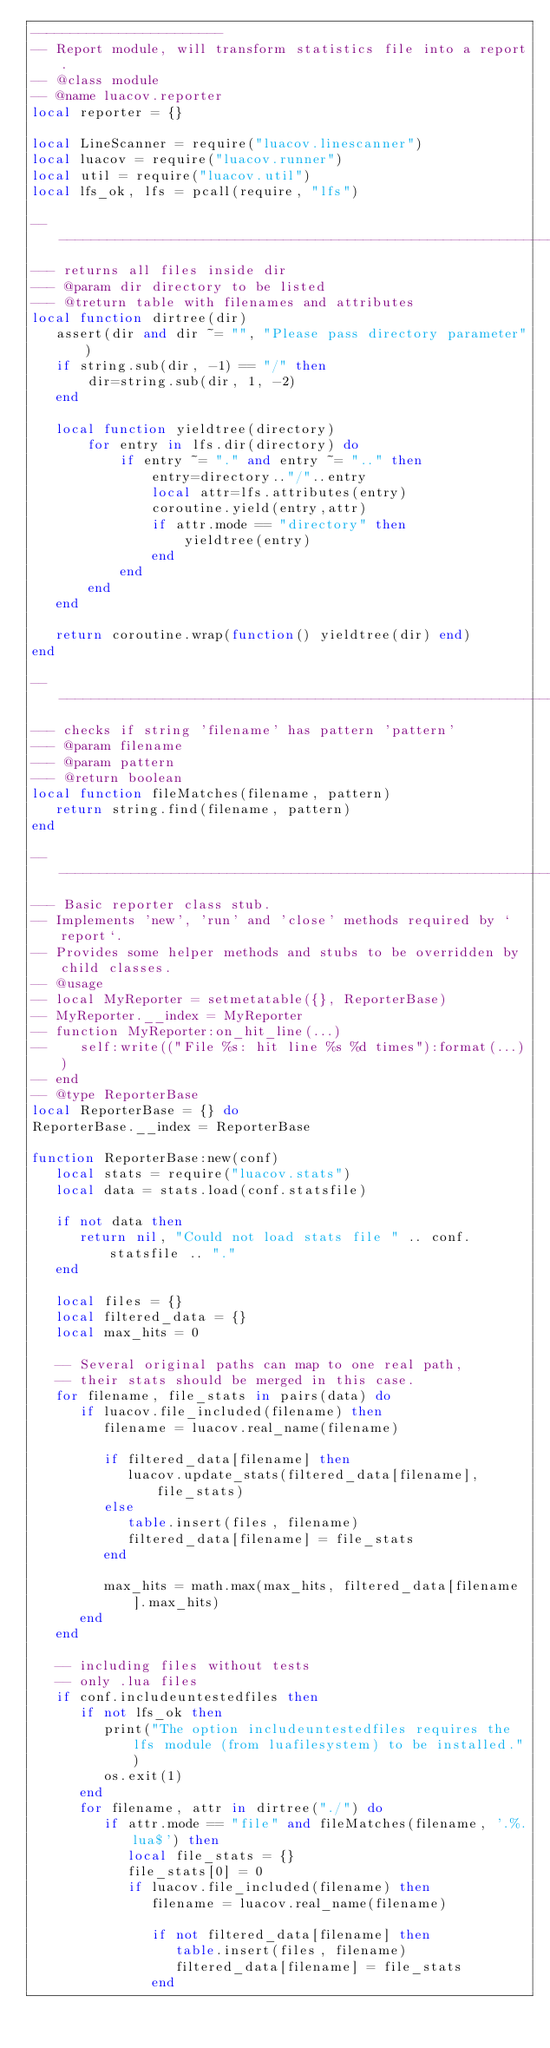<code> <loc_0><loc_0><loc_500><loc_500><_Lua_>------------------------
-- Report module, will transform statistics file into a report.
-- @class module
-- @name luacov.reporter
local reporter = {}

local LineScanner = require("luacov.linescanner")
local luacov = require("luacov.runner")
local util = require("luacov.util")
local lfs_ok, lfs = pcall(require, "lfs")

----------------------------------------------------------------
--- returns all files inside dir
--- @param dir directory to be listed
--- @treturn table with filenames and attributes
local function dirtree(dir)
   assert(dir and dir ~= "", "Please pass directory parameter")
   if string.sub(dir, -1) == "/" then
       dir=string.sub(dir, 1, -2)
   end

   local function yieldtree(directory)
       for entry in lfs.dir(directory) do
           if entry ~= "." and entry ~= ".." then
               entry=directory.."/"..entry
               local attr=lfs.attributes(entry)
               coroutine.yield(entry,attr)
               if attr.mode == "directory" then
                   yieldtree(entry)
               end
           end
       end
   end

   return coroutine.wrap(function() yieldtree(dir) end)
end

----------------------------------------------------------------
--- checks if string 'filename' has pattern 'pattern'
--- @param filename
--- @param pattern
--- @return boolean
local function fileMatches(filename, pattern)
   return string.find(filename, pattern)
end

----------------------------------------------------------------
--- Basic reporter class stub.
-- Implements 'new', 'run' and 'close' methods required by `report`.
-- Provides some helper methods and stubs to be overridden by child classes.
-- @usage
-- local MyReporter = setmetatable({}, ReporterBase)
-- MyReporter.__index = MyReporter
-- function MyReporter:on_hit_line(...)
--    self:write(("File %s: hit line %s %d times"):format(...))
-- end
-- @type ReporterBase
local ReporterBase = {} do
ReporterBase.__index = ReporterBase

function ReporterBase:new(conf)
   local stats = require("luacov.stats")
   local data = stats.load(conf.statsfile)

   if not data then
      return nil, "Could not load stats file " .. conf.statsfile .. "."
   end

   local files = {}
   local filtered_data = {}
   local max_hits = 0

   -- Several original paths can map to one real path,
   -- their stats should be merged in this case.
   for filename, file_stats in pairs(data) do
      if luacov.file_included(filename) then
         filename = luacov.real_name(filename)

         if filtered_data[filename] then
            luacov.update_stats(filtered_data[filename], file_stats)
         else
            table.insert(files, filename)
            filtered_data[filename] = file_stats
         end

         max_hits = math.max(max_hits, filtered_data[filename].max_hits)
      end
   end

   -- including files without tests
   -- only .lua files
   if conf.includeuntestedfiles then
      if not lfs_ok then
         print("The option includeuntestedfiles requires the lfs module (from luafilesystem) to be installed.")
         os.exit(1)
      end
      for filename, attr in dirtree("./") do
         if attr.mode == "file" and fileMatches(filename, '.%.lua$') then
            local file_stats = {}
            file_stats[0] = 0
            if luacov.file_included(filename) then
               filename = luacov.real_name(filename)

               if not filtered_data[filename] then
                  table.insert(files, filename)
                  filtered_data[filename] = file_stats
               end</code> 